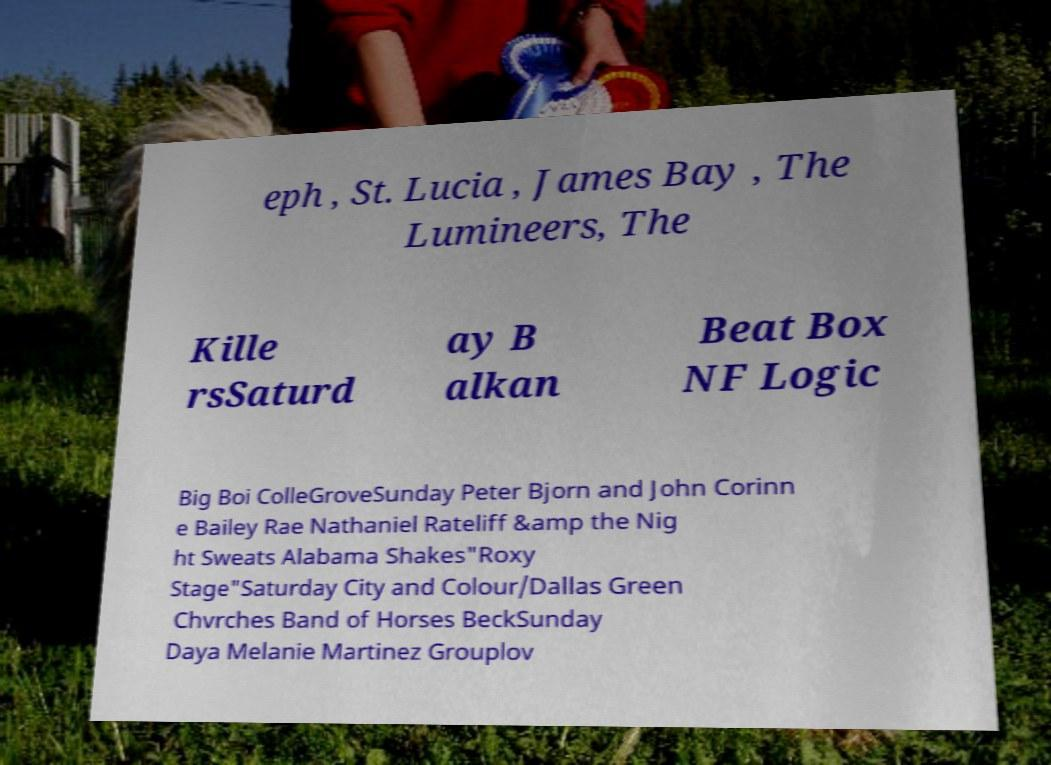Could you extract and type out the text from this image? eph , St. Lucia , James Bay , The Lumineers, The Kille rsSaturd ay B alkan Beat Box NF Logic Big Boi ColleGroveSunday Peter Bjorn and John Corinn e Bailey Rae Nathaniel Rateliff &amp the Nig ht Sweats Alabama Shakes"Roxy Stage"Saturday City and Colour/Dallas Green Chvrches Band of Horses BeckSunday Daya Melanie Martinez Grouplov 